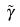Convert formula to latex. <formula><loc_0><loc_0><loc_500><loc_500>\tilde { \gamma }</formula> 